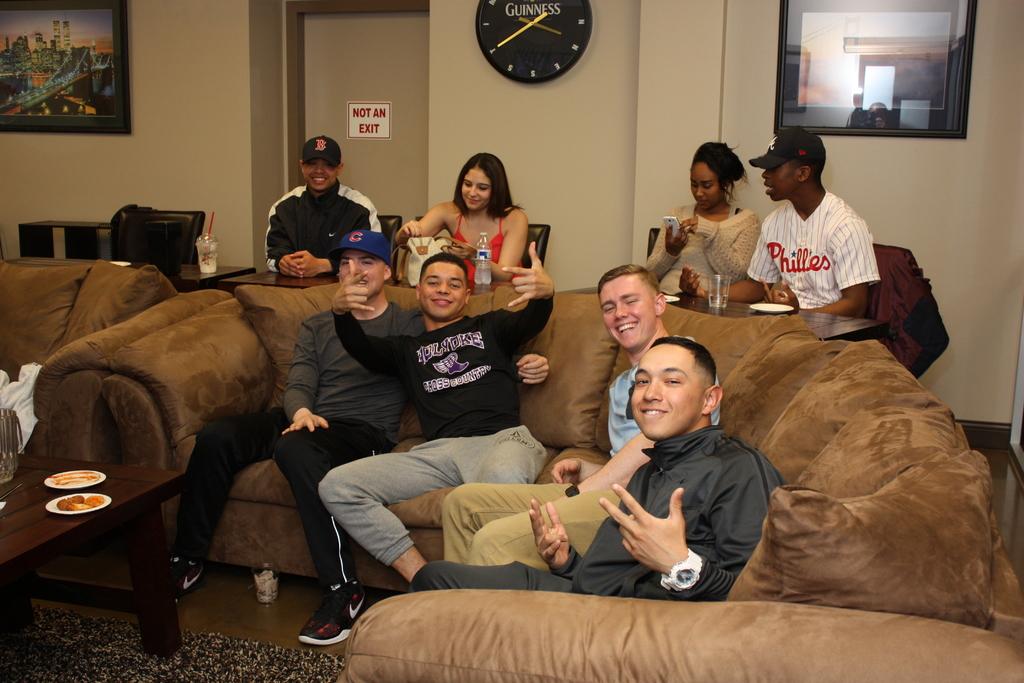What time is it?
Give a very brief answer. 3:40. 